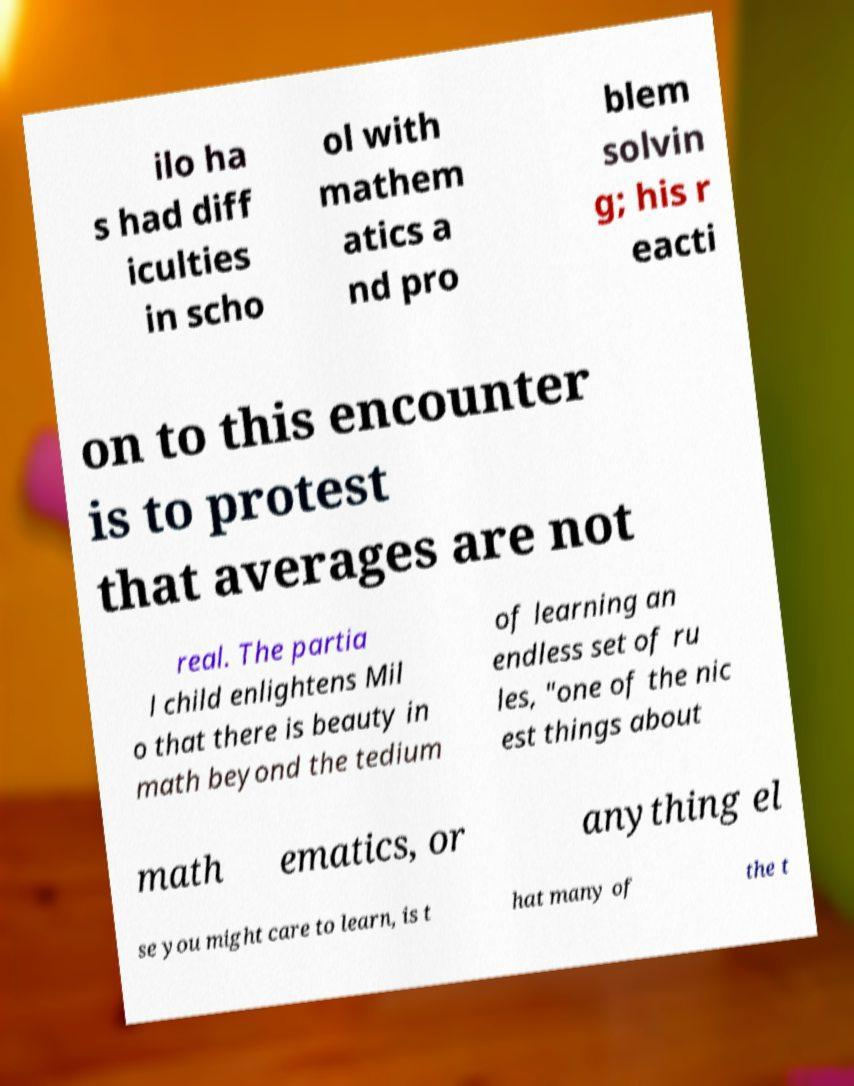Can you accurately transcribe the text from the provided image for me? ilo ha s had diff iculties in scho ol with mathem atics a nd pro blem solvin g; his r eacti on to this encounter is to protest that averages are not real. The partia l child enlightens Mil o that there is beauty in math beyond the tedium of learning an endless set of ru les, "one of the nic est things about math ematics, or anything el se you might care to learn, is t hat many of the t 